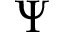Convert formula to latex. <formula><loc_0><loc_0><loc_500><loc_500>\Psi</formula> 